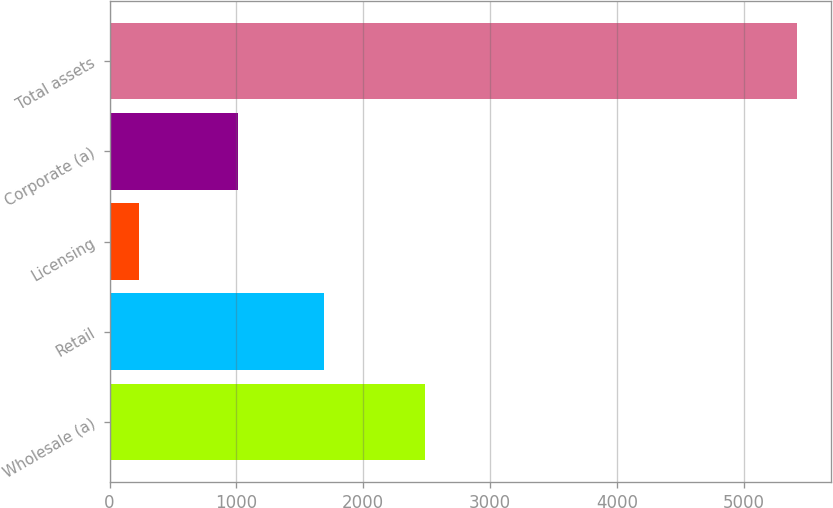Convert chart. <chart><loc_0><loc_0><loc_500><loc_500><bar_chart><fcel>Wholesale (a)<fcel>Retail<fcel>Licensing<fcel>Corporate (a)<fcel>Total assets<nl><fcel>2487.2<fcel>1691.5<fcel>228.8<fcel>1008.9<fcel>5416.4<nl></chart> 